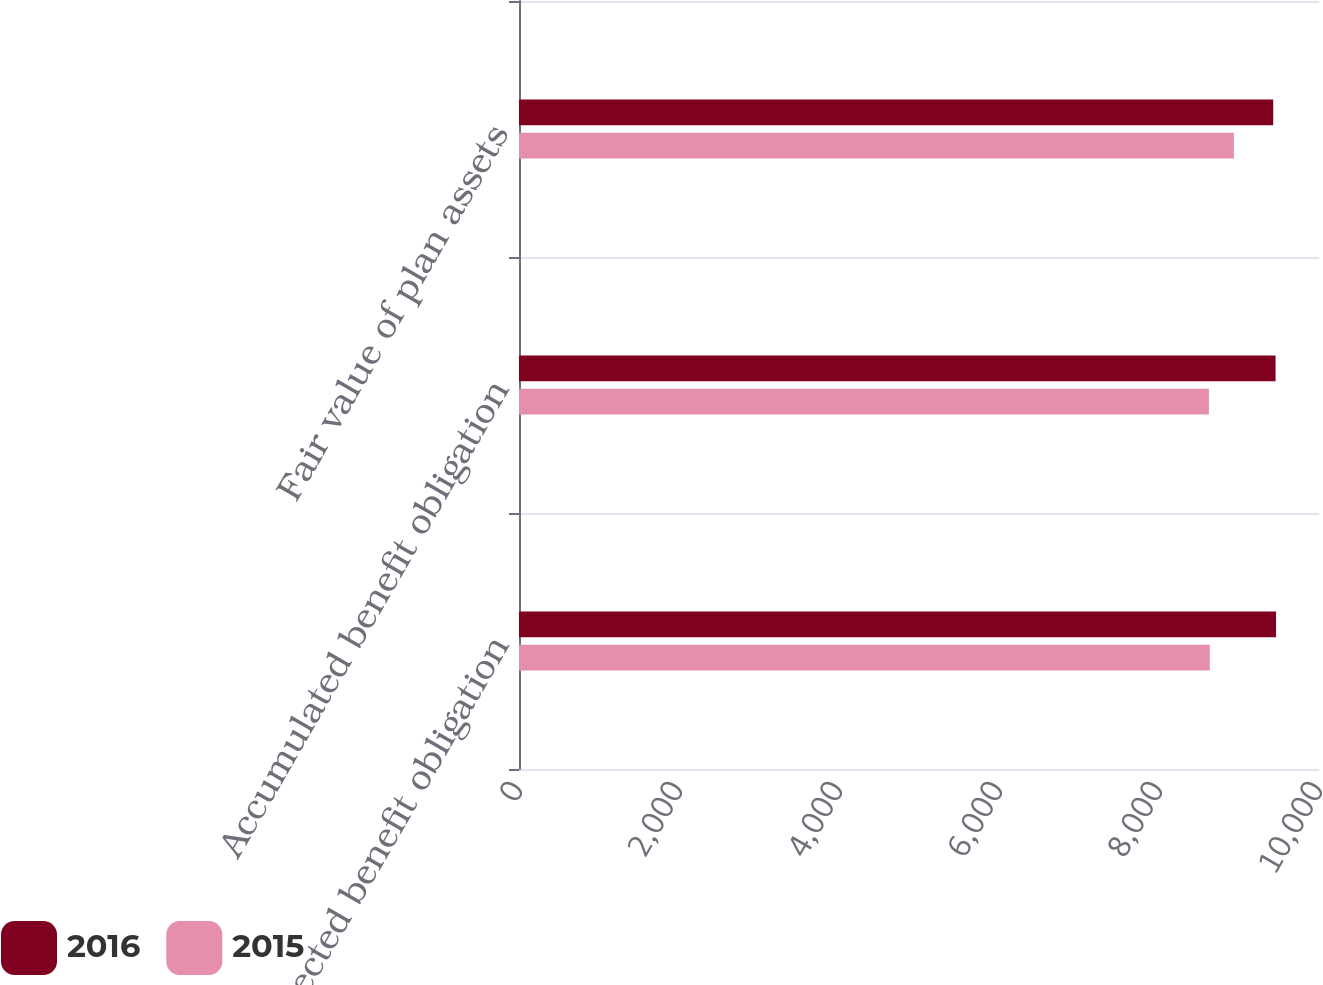Convert chart. <chart><loc_0><loc_0><loc_500><loc_500><stacked_bar_chart><ecel><fcel>Projected benefit obligation<fcel>Accumulated benefit obligation<fcel>Fair value of plan assets<nl><fcel>2016<fcel>9463<fcel>9457<fcel>9428<nl><fcel>2015<fcel>8635<fcel>8624<fcel>8936<nl></chart> 